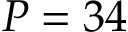Convert formula to latex. <formula><loc_0><loc_0><loc_500><loc_500>P = 3 4</formula> 